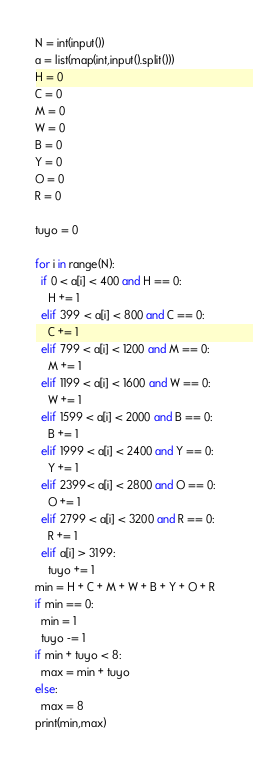Convert code to text. <code><loc_0><loc_0><loc_500><loc_500><_Python_>N = int(input())
a = list(map(int,input().split()))
H = 0
C = 0
M = 0
W = 0
B = 0
Y = 0
O = 0
R = 0

tuyo = 0

for i in range(N):
  if 0 < a[i] < 400 and H == 0:
    H += 1
  elif 399 < a[i] < 800 and C == 0:
    C += 1
  elif 799 < a[i] < 1200 and M == 0:
    M += 1
  elif 1199 < a[i] < 1600 and W == 0:
    W += 1
  elif 1599 < a[i] < 2000 and B == 0:
    B += 1
  elif 1999 < a[i] < 2400 and Y == 0:
    Y += 1
  elif 2399< a[i] < 2800 and O == 0:
    O += 1
  elif 2799 < a[i] < 3200 and R == 0:
    R += 1
  elif a[i] > 3199:
    tuyo += 1
min = H + C + M + W + B + Y + O + R 
if min == 0:
  min = 1
  tuyo -= 1
if min + tuyo < 8:
  max = min + tuyo
else:
  max = 8
print(min,max)</code> 